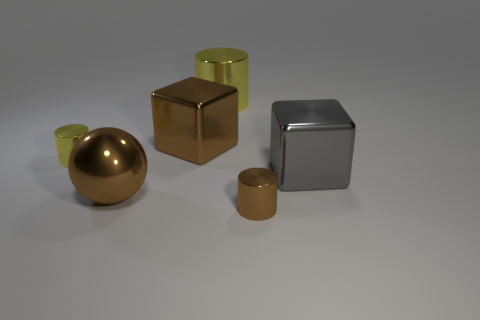Are there any big yellow shiny objects that are on the right side of the tiny metallic object that is to the right of the large yellow thing?
Offer a terse response. No. Is there any other thing that is made of the same material as the small yellow thing?
Provide a succinct answer. Yes. Is the shape of the large gray thing the same as the brown metal thing that is in front of the big brown shiny sphere?
Your answer should be very brief. No. How many other objects are there of the same size as the brown metallic sphere?
Provide a short and direct response. 3. How many purple things are big shiny cubes or shiny objects?
Offer a very short reply. 0. What number of metal objects are behind the brown metallic sphere and to the right of the brown shiny sphere?
Offer a terse response. 3. There is a small yellow cylinder behind the big object on the right side of the large object behind the large brown block; what is its material?
Provide a short and direct response. Metal. How many large gray cylinders have the same material as the brown block?
Your answer should be very brief. 0. What is the shape of the big object that is the same color as the large ball?
Make the answer very short. Cube. The brown metal object that is the same size as the brown cube is what shape?
Offer a terse response. Sphere. 